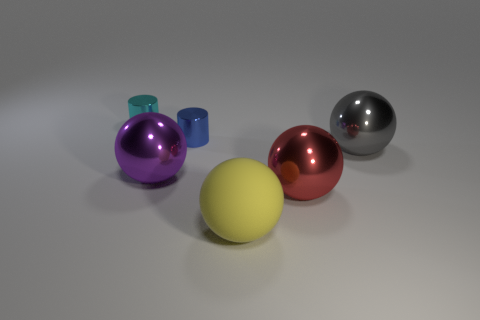There is a large metal thing that is in front of the purple ball; what shape is it?
Keep it short and to the point. Sphere. Do the sphere that is right of the large red metallic ball and the big object that is in front of the red shiny sphere have the same color?
Ensure brevity in your answer.  No. Is there a big yellow rubber object?
Offer a very short reply. Yes. There is a blue metal thing on the left side of the large metallic thing that is in front of the big metal thing that is to the left of the large rubber thing; what shape is it?
Offer a terse response. Cylinder. There is a red object; how many small cyan metal cylinders are in front of it?
Provide a short and direct response. 0. Do the large object on the left side of the yellow rubber object and the big red thing have the same material?
Your answer should be compact. Yes. How many other objects are there of the same shape as the big yellow thing?
Keep it short and to the point. 3. There is a small metal thing that is left of the big metallic thing on the left side of the red shiny sphere; what number of gray objects are behind it?
Give a very brief answer. 0. What is the color of the cylinder behind the tiny blue shiny cylinder?
Keep it short and to the point. Cyan. Is the color of the shiny ball that is on the right side of the big red sphere the same as the big rubber object?
Offer a very short reply. No. 